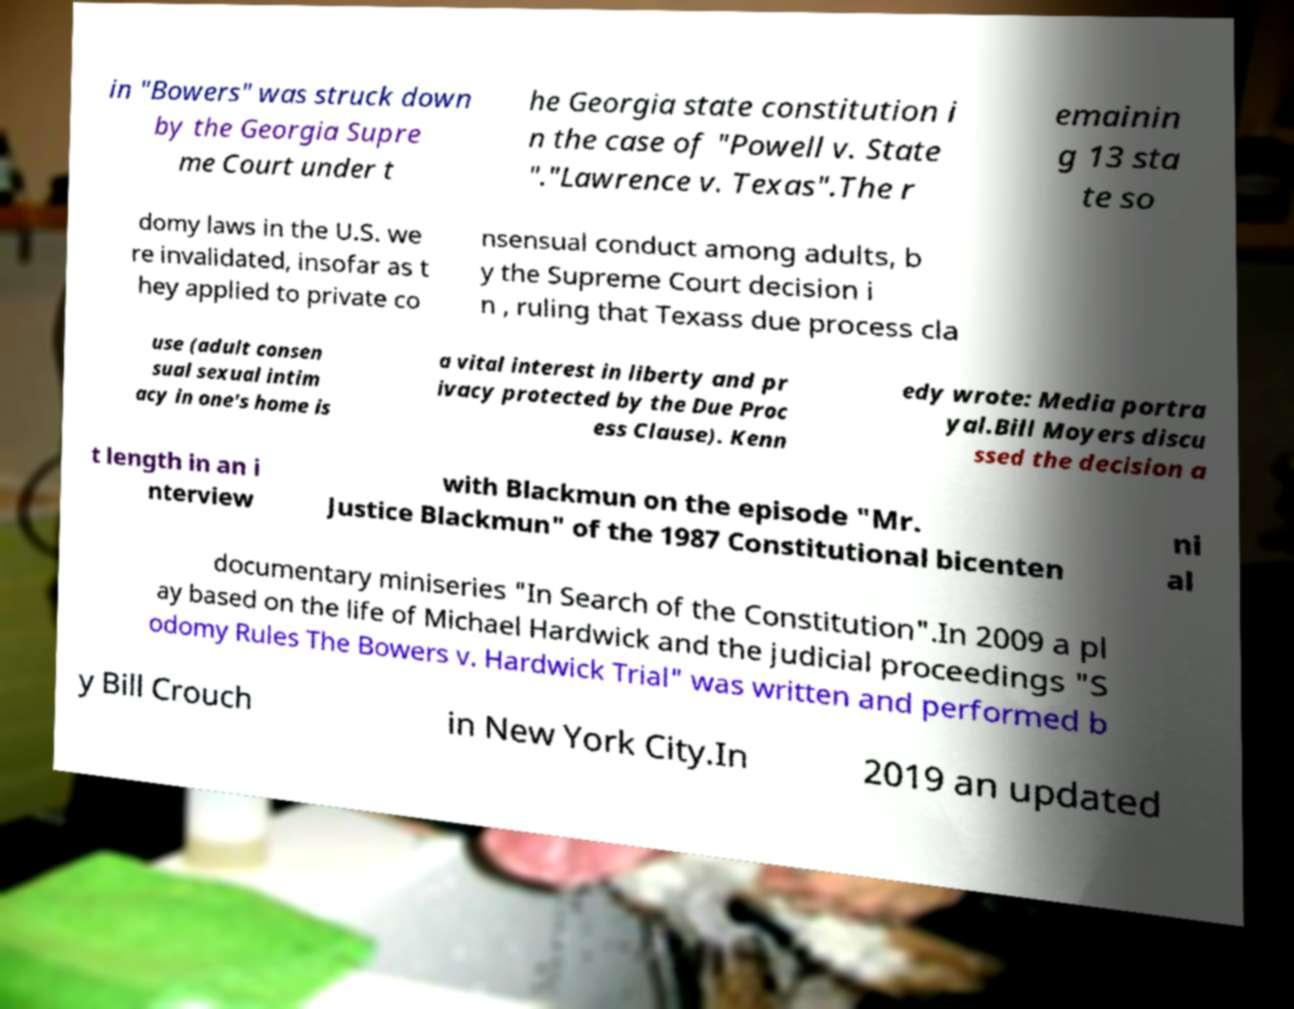Could you extract and type out the text from this image? in "Bowers" was struck down by the Georgia Supre me Court under t he Georgia state constitution i n the case of "Powell v. State "."Lawrence v. Texas".The r emainin g 13 sta te so domy laws in the U.S. we re invalidated, insofar as t hey applied to private co nsensual conduct among adults, b y the Supreme Court decision i n , ruling that Texass due process cla use (adult consen sual sexual intim acy in one's home is a vital interest in liberty and pr ivacy protected by the Due Proc ess Clause). Kenn edy wrote: Media portra yal.Bill Moyers discu ssed the decision a t length in an i nterview with Blackmun on the episode "Mr. Justice Blackmun" of the 1987 Constitutional bicenten ni al documentary miniseries "In Search of the Constitution".In 2009 a pl ay based on the life of Michael Hardwick and the judicial proceedings "S odomy Rules The Bowers v. Hardwick Trial" was written and performed b y Bill Crouch in New York City.In 2019 an updated 